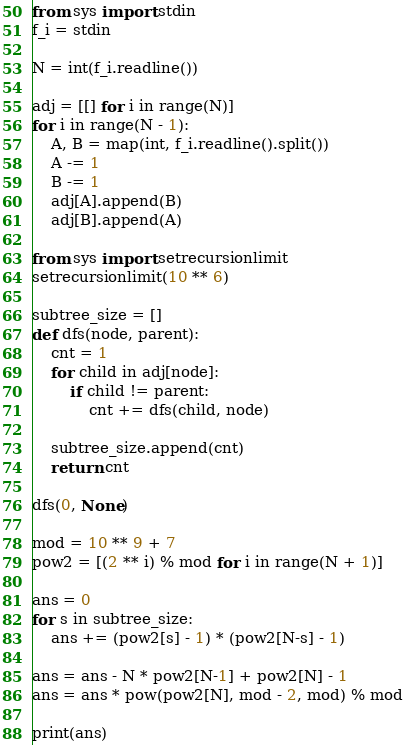Convert code to text. <code><loc_0><loc_0><loc_500><loc_500><_Python_>from sys import stdin
f_i = stdin

N = int(f_i.readline())

adj = [[] for i in range(N)]
for i in range(N - 1):
    A, B = map(int, f_i.readline().split())
    A -= 1
    B -= 1
    adj[A].append(B)
    adj[B].append(A)

from sys import setrecursionlimit
setrecursionlimit(10 ** 6)

subtree_size = []
def dfs(node, parent):
    cnt = 1
    for child in adj[node]:
        if child != parent:
            cnt += dfs(child, node)
    
    subtree_size.append(cnt)
    return cnt

dfs(0, None)

mod = 10 ** 9 + 7
pow2 = [(2 ** i) % mod for i in range(N + 1)]

ans = 0
for s in subtree_size:
    ans += (pow2[s] - 1) * (pow2[N-s] - 1)

ans = ans - N * pow2[N-1] + pow2[N] - 1
ans = ans * pow(pow2[N], mod - 2, mod) % mod

print(ans)</code> 